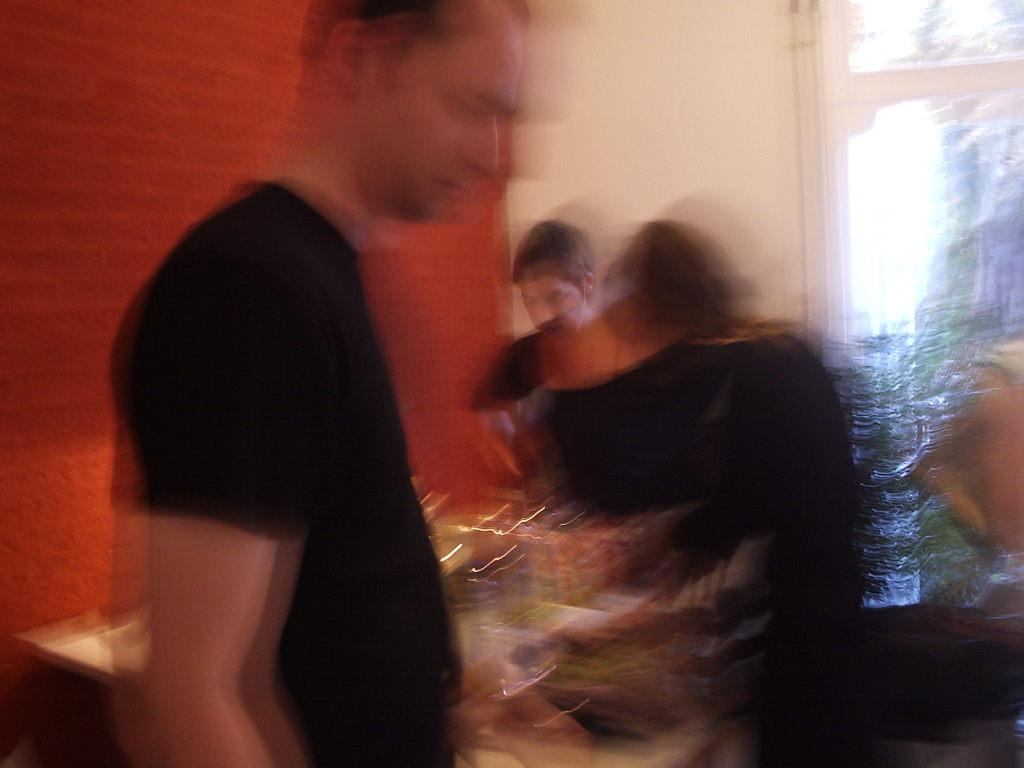How many people are in the image? There are persons in the image, but the exact number is not specified. What is behind the persons in the image? There is a wall behind the persons in the image. What can be seen on the right side of the image? There is a glass window on the right side of the image. What is visible through the window? Plants are visible through the window. What type of hand can be seen holding the plants through the window? There is no hand visible in the image; only the plants are visible through the window. 